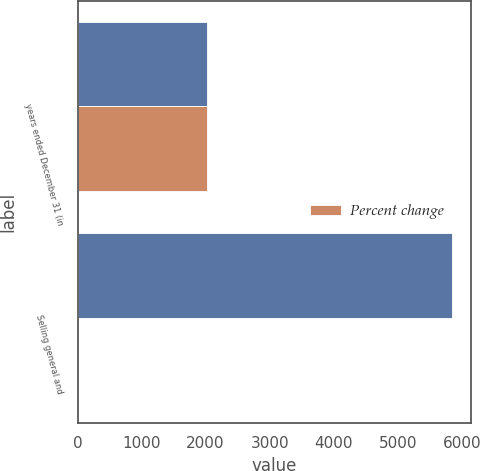Convert chart. <chart><loc_0><loc_0><loc_500><loc_500><stacked_bar_chart><ecel><fcel>years ended December 31 (in<fcel>Selling general and<nl><fcel>nan<fcel>2016<fcel>5855<nl><fcel>Percent change<fcel>2016<fcel>8<nl></chart> 